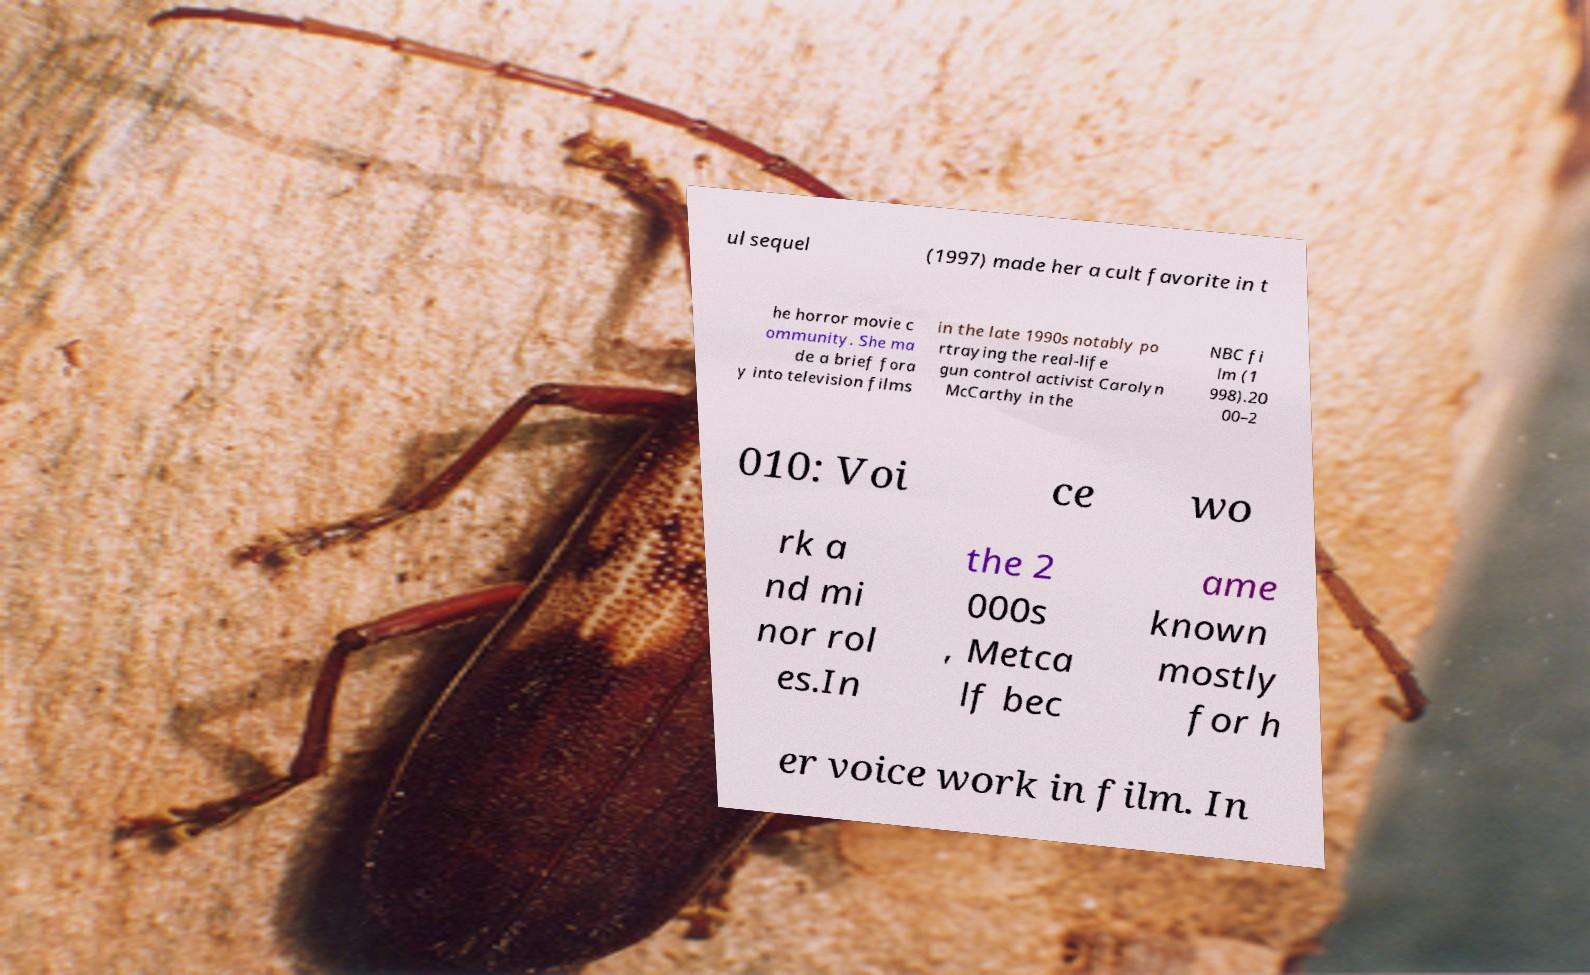Can you accurately transcribe the text from the provided image for me? ul sequel (1997) made her a cult favorite in t he horror movie c ommunity. She ma de a brief fora y into television films in the late 1990s notably po rtraying the real-life gun control activist Carolyn McCarthy in the NBC fi lm (1 998).20 00–2 010: Voi ce wo rk a nd mi nor rol es.In the 2 000s , Metca lf bec ame known mostly for h er voice work in film. In 